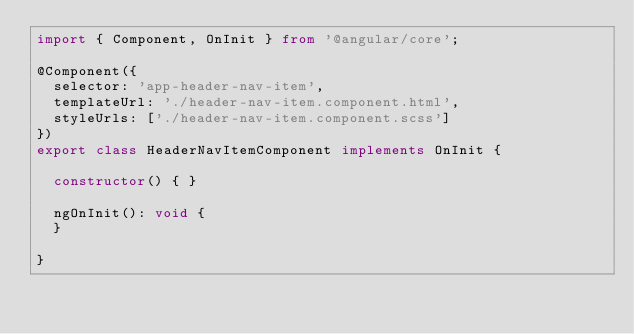Convert code to text. <code><loc_0><loc_0><loc_500><loc_500><_TypeScript_>import { Component, OnInit } from '@angular/core';

@Component({
  selector: 'app-header-nav-item',
  templateUrl: './header-nav-item.component.html',
  styleUrls: ['./header-nav-item.component.scss']
})
export class HeaderNavItemComponent implements OnInit {

  constructor() { }

  ngOnInit(): void {
  }

}
</code> 